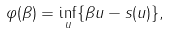<formula> <loc_0><loc_0><loc_500><loc_500>\varphi ( \beta ) = \inf _ { u } \{ \beta u - s ( u ) \} ,</formula> 